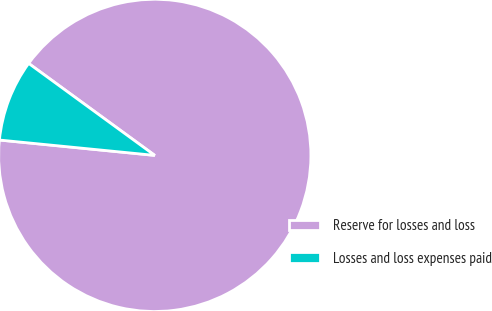Convert chart to OTSL. <chart><loc_0><loc_0><loc_500><loc_500><pie_chart><fcel>Reserve for losses and loss<fcel>Losses and loss expenses paid<nl><fcel>91.54%<fcel>8.46%<nl></chart> 